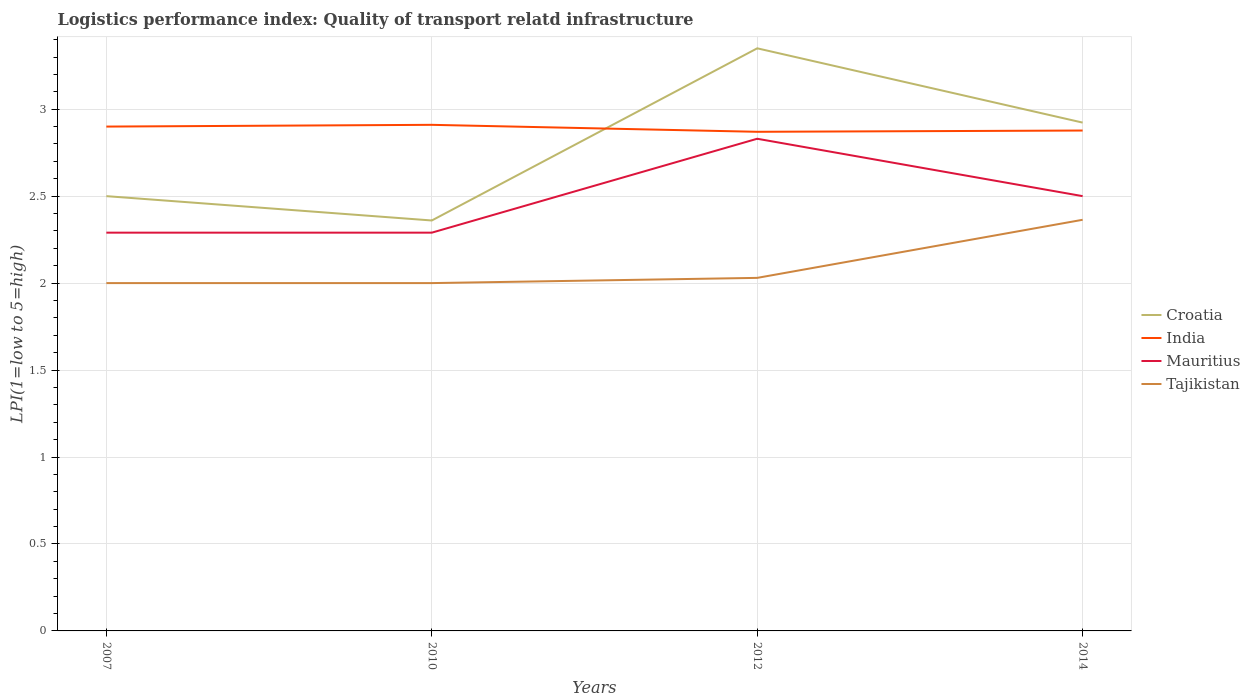Across all years, what is the maximum logistics performance index in Croatia?
Ensure brevity in your answer.  2.36. What is the total logistics performance index in Mauritius in the graph?
Your response must be concise. 0.33. What is the difference between the highest and the second highest logistics performance index in Croatia?
Your response must be concise. 0.99. Is the logistics performance index in India strictly greater than the logistics performance index in Tajikistan over the years?
Provide a short and direct response. No. How many lines are there?
Offer a very short reply. 4. How many years are there in the graph?
Your response must be concise. 4. What is the difference between two consecutive major ticks on the Y-axis?
Give a very brief answer. 0.5. Where does the legend appear in the graph?
Give a very brief answer. Center right. How many legend labels are there?
Make the answer very short. 4. What is the title of the graph?
Offer a very short reply. Logistics performance index: Quality of transport relatd infrastructure. What is the label or title of the Y-axis?
Ensure brevity in your answer.  LPI(1=low to 5=high). What is the LPI(1=low to 5=high) of Croatia in 2007?
Your answer should be very brief. 2.5. What is the LPI(1=low to 5=high) of Mauritius in 2007?
Your answer should be compact. 2.29. What is the LPI(1=low to 5=high) in Tajikistan in 2007?
Your response must be concise. 2. What is the LPI(1=low to 5=high) of Croatia in 2010?
Your response must be concise. 2.36. What is the LPI(1=low to 5=high) in India in 2010?
Your response must be concise. 2.91. What is the LPI(1=low to 5=high) of Mauritius in 2010?
Provide a short and direct response. 2.29. What is the LPI(1=low to 5=high) of Tajikistan in 2010?
Ensure brevity in your answer.  2. What is the LPI(1=low to 5=high) of Croatia in 2012?
Provide a succinct answer. 3.35. What is the LPI(1=low to 5=high) in India in 2012?
Provide a succinct answer. 2.87. What is the LPI(1=low to 5=high) in Mauritius in 2012?
Make the answer very short. 2.83. What is the LPI(1=low to 5=high) in Tajikistan in 2012?
Make the answer very short. 2.03. What is the LPI(1=low to 5=high) of Croatia in 2014?
Keep it short and to the point. 2.92. What is the LPI(1=low to 5=high) of India in 2014?
Your answer should be very brief. 2.88. What is the LPI(1=low to 5=high) of Tajikistan in 2014?
Give a very brief answer. 2.36. Across all years, what is the maximum LPI(1=low to 5=high) of Croatia?
Provide a succinct answer. 3.35. Across all years, what is the maximum LPI(1=low to 5=high) in India?
Offer a terse response. 2.91. Across all years, what is the maximum LPI(1=low to 5=high) in Mauritius?
Your response must be concise. 2.83. Across all years, what is the maximum LPI(1=low to 5=high) in Tajikistan?
Make the answer very short. 2.36. Across all years, what is the minimum LPI(1=low to 5=high) in Croatia?
Offer a terse response. 2.36. Across all years, what is the minimum LPI(1=low to 5=high) of India?
Make the answer very short. 2.87. Across all years, what is the minimum LPI(1=low to 5=high) of Mauritius?
Make the answer very short. 2.29. Across all years, what is the minimum LPI(1=low to 5=high) in Tajikistan?
Keep it short and to the point. 2. What is the total LPI(1=low to 5=high) of Croatia in the graph?
Your response must be concise. 11.13. What is the total LPI(1=low to 5=high) in India in the graph?
Your response must be concise. 11.56. What is the total LPI(1=low to 5=high) in Mauritius in the graph?
Ensure brevity in your answer.  9.91. What is the total LPI(1=low to 5=high) of Tajikistan in the graph?
Ensure brevity in your answer.  8.39. What is the difference between the LPI(1=low to 5=high) in Croatia in 2007 and that in 2010?
Provide a short and direct response. 0.14. What is the difference between the LPI(1=low to 5=high) of India in 2007 and that in 2010?
Your response must be concise. -0.01. What is the difference between the LPI(1=low to 5=high) of Croatia in 2007 and that in 2012?
Your answer should be very brief. -0.85. What is the difference between the LPI(1=low to 5=high) in Mauritius in 2007 and that in 2012?
Your answer should be compact. -0.54. What is the difference between the LPI(1=low to 5=high) in Tajikistan in 2007 and that in 2012?
Ensure brevity in your answer.  -0.03. What is the difference between the LPI(1=low to 5=high) in Croatia in 2007 and that in 2014?
Your answer should be very brief. -0.42. What is the difference between the LPI(1=low to 5=high) of India in 2007 and that in 2014?
Keep it short and to the point. 0.02. What is the difference between the LPI(1=low to 5=high) of Mauritius in 2007 and that in 2014?
Offer a very short reply. -0.21. What is the difference between the LPI(1=low to 5=high) in Tajikistan in 2007 and that in 2014?
Offer a very short reply. -0.36. What is the difference between the LPI(1=low to 5=high) in Croatia in 2010 and that in 2012?
Your response must be concise. -0.99. What is the difference between the LPI(1=low to 5=high) of India in 2010 and that in 2012?
Provide a succinct answer. 0.04. What is the difference between the LPI(1=low to 5=high) of Mauritius in 2010 and that in 2012?
Your response must be concise. -0.54. What is the difference between the LPI(1=low to 5=high) of Tajikistan in 2010 and that in 2012?
Your answer should be very brief. -0.03. What is the difference between the LPI(1=low to 5=high) in Croatia in 2010 and that in 2014?
Ensure brevity in your answer.  -0.56. What is the difference between the LPI(1=low to 5=high) of India in 2010 and that in 2014?
Provide a short and direct response. 0.03. What is the difference between the LPI(1=low to 5=high) of Mauritius in 2010 and that in 2014?
Keep it short and to the point. -0.21. What is the difference between the LPI(1=low to 5=high) in Tajikistan in 2010 and that in 2014?
Your answer should be very brief. -0.36. What is the difference between the LPI(1=low to 5=high) of Croatia in 2012 and that in 2014?
Offer a very short reply. 0.43. What is the difference between the LPI(1=low to 5=high) of India in 2012 and that in 2014?
Ensure brevity in your answer.  -0.01. What is the difference between the LPI(1=low to 5=high) of Mauritius in 2012 and that in 2014?
Keep it short and to the point. 0.33. What is the difference between the LPI(1=low to 5=high) in Tajikistan in 2012 and that in 2014?
Make the answer very short. -0.33. What is the difference between the LPI(1=low to 5=high) in Croatia in 2007 and the LPI(1=low to 5=high) in India in 2010?
Offer a terse response. -0.41. What is the difference between the LPI(1=low to 5=high) of Croatia in 2007 and the LPI(1=low to 5=high) of Mauritius in 2010?
Ensure brevity in your answer.  0.21. What is the difference between the LPI(1=low to 5=high) in India in 2007 and the LPI(1=low to 5=high) in Mauritius in 2010?
Your answer should be compact. 0.61. What is the difference between the LPI(1=low to 5=high) of India in 2007 and the LPI(1=low to 5=high) of Tajikistan in 2010?
Provide a short and direct response. 0.9. What is the difference between the LPI(1=low to 5=high) of Mauritius in 2007 and the LPI(1=low to 5=high) of Tajikistan in 2010?
Give a very brief answer. 0.29. What is the difference between the LPI(1=low to 5=high) in Croatia in 2007 and the LPI(1=low to 5=high) in India in 2012?
Make the answer very short. -0.37. What is the difference between the LPI(1=low to 5=high) in Croatia in 2007 and the LPI(1=low to 5=high) in Mauritius in 2012?
Offer a very short reply. -0.33. What is the difference between the LPI(1=low to 5=high) of Croatia in 2007 and the LPI(1=low to 5=high) of Tajikistan in 2012?
Give a very brief answer. 0.47. What is the difference between the LPI(1=low to 5=high) in India in 2007 and the LPI(1=low to 5=high) in Mauritius in 2012?
Offer a very short reply. 0.07. What is the difference between the LPI(1=low to 5=high) of India in 2007 and the LPI(1=low to 5=high) of Tajikistan in 2012?
Offer a terse response. 0.87. What is the difference between the LPI(1=low to 5=high) of Mauritius in 2007 and the LPI(1=low to 5=high) of Tajikistan in 2012?
Provide a succinct answer. 0.26. What is the difference between the LPI(1=low to 5=high) of Croatia in 2007 and the LPI(1=low to 5=high) of India in 2014?
Your response must be concise. -0.38. What is the difference between the LPI(1=low to 5=high) of Croatia in 2007 and the LPI(1=low to 5=high) of Mauritius in 2014?
Your response must be concise. 0. What is the difference between the LPI(1=low to 5=high) of Croatia in 2007 and the LPI(1=low to 5=high) of Tajikistan in 2014?
Your answer should be compact. 0.14. What is the difference between the LPI(1=low to 5=high) of India in 2007 and the LPI(1=low to 5=high) of Mauritius in 2014?
Offer a very short reply. 0.4. What is the difference between the LPI(1=low to 5=high) in India in 2007 and the LPI(1=low to 5=high) in Tajikistan in 2014?
Your answer should be compact. 0.54. What is the difference between the LPI(1=low to 5=high) in Mauritius in 2007 and the LPI(1=low to 5=high) in Tajikistan in 2014?
Provide a short and direct response. -0.07. What is the difference between the LPI(1=low to 5=high) in Croatia in 2010 and the LPI(1=low to 5=high) in India in 2012?
Make the answer very short. -0.51. What is the difference between the LPI(1=low to 5=high) of Croatia in 2010 and the LPI(1=low to 5=high) of Mauritius in 2012?
Provide a succinct answer. -0.47. What is the difference between the LPI(1=low to 5=high) of Croatia in 2010 and the LPI(1=low to 5=high) of Tajikistan in 2012?
Offer a very short reply. 0.33. What is the difference between the LPI(1=low to 5=high) in India in 2010 and the LPI(1=low to 5=high) in Tajikistan in 2012?
Offer a terse response. 0.88. What is the difference between the LPI(1=low to 5=high) of Mauritius in 2010 and the LPI(1=low to 5=high) of Tajikistan in 2012?
Ensure brevity in your answer.  0.26. What is the difference between the LPI(1=low to 5=high) in Croatia in 2010 and the LPI(1=low to 5=high) in India in 2014?
Provide a short and direct response. -0.52. What is the difference between the LPI(1=low to 5=high) of Croatia in 2010 and the LPI(1=low to 5=high) of Mauritius in 2014?
Make the answer very short. -0.14. What is the difference between the LPI(1=low to 5=high) in Croatia in 2010 and the LPI(1=low to 5=high) in Tajikistan in 2014?
Make the answer very short. -0. What is the difference between the LPI(1=low to 5=high) of India in 2010 and the LPI(1=low to 5=high) of Mauritius in 2014?
Make the answer very short. 0.41. What is the difference between the LPI(1=low to 5=high) of India in 2010 and the LPI(1=low to 5=high) of Tajikistan in 2014?
Keep it short and to the point. 0.55. What is the difference between the LPI(1=low to 5=high) in Mauritius in 2010 and the LPI(1=low to 5=high) in Tajikistan in 2014?
Ensure brevity in your answer.  -0.07. What is the difference between the LPI(1=low to 5=high) of Croatia in 2012 and the LPI(1=low to 5=high) of India in 2014?
Offer a terse response. 0.47. What is the difference between the LPI(1=low to 5=high) of Croatia in 2012 and the LPI(1=low to 5=high) of Mauritius in 2014?
Your response must be concise. 0.85. What is the difference between the LPI(1=low to 5=high) in Croatia in 2012 and the LPI(1=low to 5=high) in Tajikistan in 2014?
Make the answer very short. 0.99. What is the difference between the LPI(1=low to 5=high) of India in 2012 and the LPI(1=low to 5=high) of Mauritius in 2014?
Offer a terse response. 0.37. What is the difference between the LPI(1=low to 5=high) of India in 2012 and the LPI(1=low to 5=high) of Tajikistan in 2014?
Keep it short and to the point. 0.51. What is the difference between the LPI(1=low to 5=high) in Mauritius in 2012 and the LPI(1=low to 5=high) in Tajikistan in 2014?
Offer a terse response. 0.47. What is the average LPI(1=low to 5=high) of Croatia per year?
Offer a very short reply. 2.78. What is the average LPI(1=low to 5=high) of India per year?
Provide a succinct answer. 2.89. What is the average LPI(1=low to 5=high) in Mauritius per year?
Make the answer very short. 2.48. What is the average LPI(1=low to 5=high) of Tajikistan per year?
Offer a terse response. 2.1. In the year 2007, what is the difference between the LPI(1=low to 5=high) in Croatia and LPI(1=low to 5=high) in India?
Make the answer very short. -0.4. In the year 2007, what is the difference between the LPI(1=low to 5=high) in Croatia and LPI(1=low to 5=high) in Mauritius?
Your response must be concise. 0.21. In the year 2007, what is the difference between the LPI(1=low to 5=high) of India and LPI(1=low to 5=high) of Mauritius?
Your answer should be compact. 0.61. In the year 2007, what is the difference between the LPI(1=low to 5=high) of Mauritius and LPI(1=low to 5=high) of Tajikistan?
Offer a terse response. 0.29. In the year 2010, what is the difference between the LPI(1=low to 5=high) of Croatia and LPI(1=low to 5=high) of India?
Provide a succinct answer. -0.55. In the year 2010, what is the difference between the LPI(1=low to 5=high) in Croatia and LPI(1=low to 5=high) in Mauritius?
Your answer should be compact. 0.07. In the year 2010, what is the difference between the LPI(1=low to 5=high) in Croatia and LPI(1=low to 5=high) in Tajikistan?
Ensure brevity in your answer.  0.36. In the year 2010, what is the difference between the LPI(1=low to 5=high) in India and LPI(1=low to 5=high) in Mauritius?
Your answer should be compact. 0.62. In the year 2010, what is the difference between the LPI(1=low to 5=high) in India and LPI(1=low to 5=high) in Tajikistan?
Provide a succinct answer. 0.91. In the year 2010, what is the difference between the LPI(1=low to 5=high) in Mauritius and LPI(1=low to 5=high) in Tajikistan?
Ensure brevity in your answer.  0.29. In the year 2012, what is the difference between the LPI(1=low to 5=high) in Croatia and LPI(1=low to 5=high) in India?
Provide a short and direct response. 0.48. In the year 2012, what is the difference between the LPI(1=low to 5=high) in Croatia and LPI(1=low to 5=high) in Mauritius?
Offer a very short reply. 0.52. In the year 2012, what is the difference between the LPI(1=low to 5=high) in Croatia and LPI(1=low to 5=high) in Tajikistan?
Offer a terse response. 1.32. In the year 2012, what is the difference between the LPI(1=low to 5=high) in India and LPI(1=low to 5=high) in Mauritius?
Provide a succinct answer. 0.04. In the year 2012, what is the difference between the LPI(1=low to 5=high) of India and LPI(1=low to 5=high) of Tajikistan?
Keep it short and to the point. 0.84. In the year 2012, what is the difference between the LPI(1=low to 5=high) in Mauritius and LPI(1=low to 5=high) in Tajikistan?
Ensure brevity in your answer.  0.8. In the year 2014, what is the difference between the LPI(1=low to 5=high) of Croatia and LPI(1=low to 5=high) of India?
Keep it short and to the point. 0.05. In the year 2014, what is the difference between the LPI(1=low to 5=high) in Croatia and LPI(1=low to 5=high) in Mauritius?
Your response must be concise. 0.42. In the year 2014, what is the difference between the LPI(1=low to 5=high) in Croatia and LPI(1=low to 5=high) in Tajikistan?
Provide a succinct answer. 0.56. In the year 2014, what is the difference between the LPI(1=low to 5=high) in India and LPI(1=low to 5=high) in Mauritius?
Your answer should be very brief. 0.38. In the year 2014, what is the difference between the LPI(1=low to 5=high) in India and LPI(1=low to 5=high) in Tajikistan?
Ensure brevity in your answer.  0.51. In the year 2014, what is the difference between the LPI(1=low to 5=high) of Mauritius and LPI(1=low to 5=high) of Tajikistan?
Provide a short and direct response. 0.14. What is the ratio of the LPI(1=low to 5=high) in Croatia in 2007 to that in 2010?
Your answer should be compact. 1.06. What is the ratio of the LPI(1=low to 5=high) of Mauritius in 2007 to that in 2010?
Offer a very short reply. 1. What is the ratio of the LPI(1=low to 5=high) of Tajikistan in 2007 to that in 2010?
Your answer should be very brief. 1. What is the ratio of the LPI(1=low to 5=high) in Croatia in 2007 to that in 2012?
Offer a very short reply. 0.75. What is the ratio of the LPI(1=low to 5=high) of India in 2007 to that in 2012?
Keep it short and to the point. 1.01. What is the ratio of the LPI(1=low to 5=high) of Mauritius in 2007 to that in 2012?
Your answer should be very brief. 0.81. What is the ratio of the LPI(1=low to 5=high) of Tajikistan in 2007 to that in 2012?
Give a very brief answer. 0.99. What is the ratio of the LPI(1=low to 5=high) in Croatia in 2007 to that in 2014?
Offer a terse response. 0.86. What is the ratio of the LPI(1=low to 5=high) in India in 2007 to that in 2014?
Provide a succinct answer. 1.01. What is the ratio of the LPI(1=low to 5=high) of Mauritius in 2007 to that in 2014?
Keep it short and to the point. 0.92. What is the ratio of the LPI(1=low to 5=high) in Tajikistan in 2007 to that in 2014?
Offer a very short reply. 0.85. What is the ratio of the LPI(1=low to 5=high) of Croatia in 2010 to that in 2012?
Give a very brief answer. 0.7. What is the ratio of the LPI(1=low to 5=high) of India in 2010 to that in 2012?
Offer a terse response. 1.01. What is the ratio of the LPI(1=low to 5=high) in Mauritius in 2010 to that in 2012?
Keep it short and to the point. 0.81. What is the ratio of the LPI(1=low to 5=high) in Tajikistan in 2010 to that in 2012?
Give a very brief answer. 0.99. What is the ratio of the LPI(1=low to 5=high) in Croatia in 2010 to that in 2014?
Your answer should be compact. 0.81. What is the ratio of the LPI(1=low to 5=high) of India in 2010 to that in 2014?
Offer a terse response. 1.01. What is the ratio of the LPI(1=low to 5=high) of Mauritius in 2010 to that in 2014?
Provide a succinct answer. 0.92. What is the ratio of the LPI(1=low to 5=high) of Tajikistan in 2010 to that in 2014?
Ensure brevity in your answer.  0.85. What is the ratio of the LPI(1=low to 5=high) of Croatia in 2012 to that in 2014?
Keep it short and to the point. 1.15. What is the ratio of the LPI(1=low to 5=high) of India in 2012 to that in 2014?
Make the answer very short. 1. What is the ratio of the LPI(1=low to 5=high) in Mauritius in 2012 to that in 2014?
Give a very brief answer. 1.13. What is the ratio of the LPI(1=low to 5=high) in Tajikistan in 2012 to that in 2014?
Your answer should be very brief. 0.86. What is the difference between the highest and the second highest LPI(1=low to 5=high) of Croatia?
Offer a terse response. 0.43. What is the difference between the highest and the second highest LPI(1=low to 5=high) of Mauritius?
Make the answer very short. 0.33. What is the difference between the highest and the second highest LPI(1=low to 5=high) of Tajikistan?
Provide a short and direct response. 0.33. What is the difference between the highest and the lowest LPI(1=low to 5=high) in Mauritius?
Provide a succinct answer. 0.54. What is the difference between the highest and the lowest LPI(1=low to 5=high) of Tajikistan?
Your answer should be compact. 0.36. 